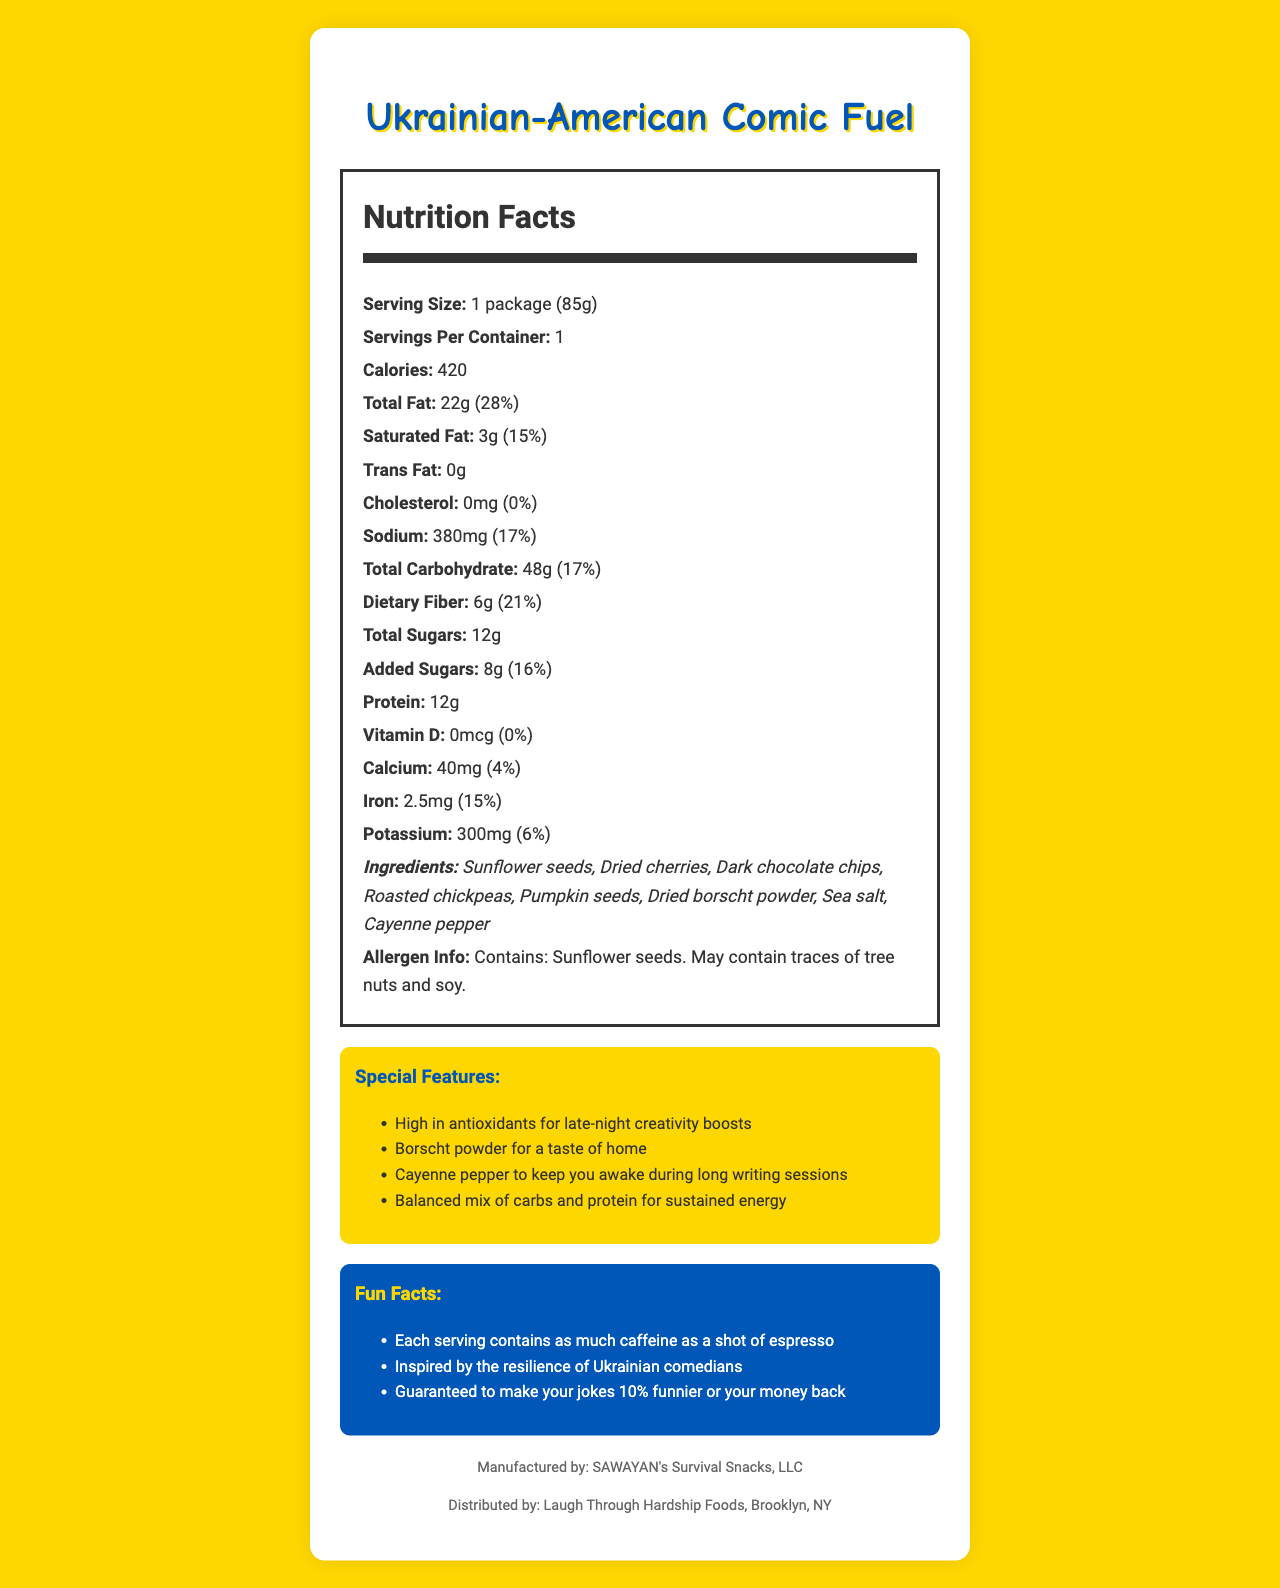what is the serving size? The serving size is specified on the Nutrition Facts Label under "Serving Size."
Answer: 1 package (85g) how many calories are in one package of the "Ukrainian-American Comic Fuel"? The number of calories per serving is directly listed on the Nutrition Facts Label as 420 calories.
Answer: 420 calories how much sodium does one serving contain? The amount of sodium per serving is listed on the Nutrition Facts Label as 380mg.
Answer: 380mg what percentage of the daily value for iron does one serving provide? The percentage of the daily value for iron is listed on the Nutrition Facts Label as 15%.
Answer: 15% how many grams of protein are in one package? The amount of protein per serving is listed on the Nutrition Facts Label as 12g.
Answer: 12g what are the key features of this product designed to help comedians? A. High in antioxidants B. Contains borscht powder C. Balanced mix of carbs and protein D. Contains caffeine All these features are described under the "Special Features" section.
Answer: A, B, C, D what is the total fat content, and what is its daily value percentage? A. 28g, 22% B. 22g, 28% C. 28g, 22% D. 22g, 15% The total fat content is 22g, which is 28% of the daily value, as stated on the Nutrition Facts Label.
Answer: B. 22g, 28% are there any traces of tree nuts or soy in this product? The allergen information states that the product may contain traces of tree nuts and soy.
Answer: Yes are there any fun facts mentioned about the product? There is a "Fun Facts" section that provides several items, such as each serving containing as much caffeine as a shot of espresso.
Answer: Yes how is this product related to Ukrainian comedians? One of the fun facts mentions that the snack is inspired by the resilience of Ukrainian comedians.
Answer: Inspired by the resilience of Ukrainian comedians what is the main idea of the document? The document combines nutritional data, ingredient lists, allergen information, special features, and fun facts, aiming to support the dietary needs and mental resilience of comedians.
Answer: The document provides the nutritional information, ingredients, and special features of "Ukrainian-American Comic Fuel," a snack designed to support comedians with energy, creativity, and a taste of home. It highlights its balance of fats, carbohydrates, and protein, ingredients like borscht powder, and additional fun facts. what is the source of borscht flavor in the product? The ingredients list mentions dried borscht powder as an ingredient.
Answer: Dried borscht powder does the product contain any added sugars? The Nutrition Facts Label states that there are 8g of added sugars.
Answer: Yes, 8g what company manufactures this product? The footer of the document states that the manufacturer is SAWAYAN's Survival Snacks, LLC.
Answer: SAWAYAN's Survival Snacks, LLC is there any information about the caffeine content in the product? One of the fun facts mentions the caffeine content equivalent to a shot of espresso.
Answer: Yes, each serving contains as much caffeine as a shot of espresso how much dietary fiber is in one package? The dietary fiber content listed on the Nutrition Facts Label is 6g.
Answer: 6g what is the daily value percentage for calcium provided by one serving? The daily value percentage for calcium is listed as 4%.
Answer: 4% who distributes the product? The footer of the document states that the product is distributed by Laugh Through Hardship Foods, Brooklyn, NY.
Answer: Laugh Through Hardship Foods, Brooklyn, NY how much cholesterol does this product contain? The Nutrition Facts Label shows that the product contains 0mg of cholesterol.
Answer: 0mg how many servings are in one container? The Nutrition Facts Label states that there is 1 serving per container.
Answer: 1 what ingredient mentioned is likely to give a spicy kick to the snack? The ingredients list includes cayenne pepper, which is known for its spiciness.
Answer: Cayenne pepper why might you not be able to determine the manufacturing date of the product? The document does not provide any details on the manufacturing date of the product.
Answer: Not enough information 